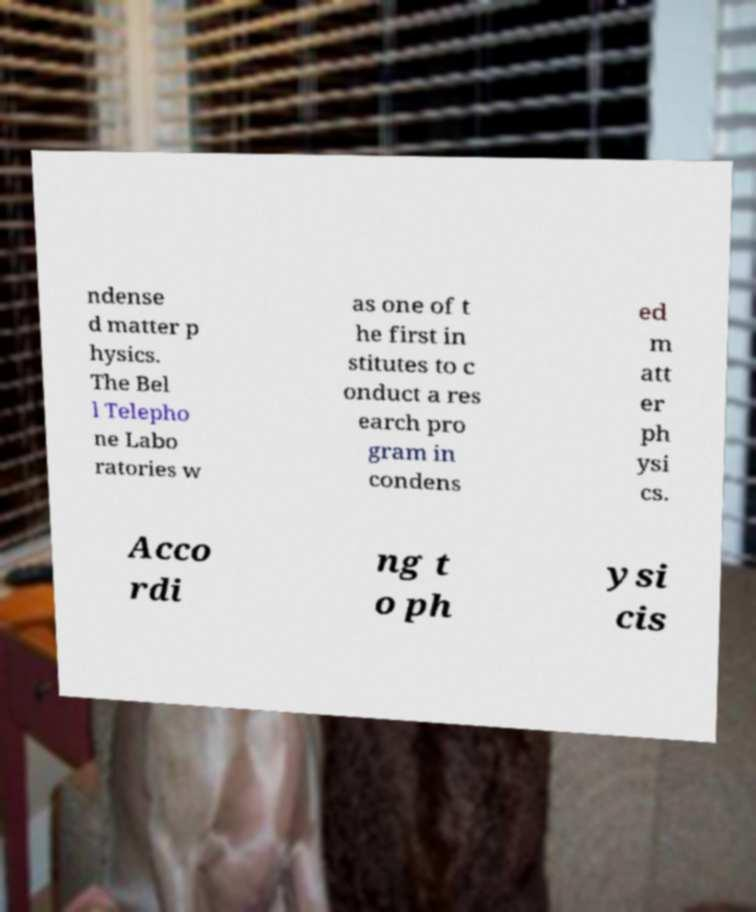Please identify and transcribe the text found in this image. ndense d matter p hysics. The Bel l Telepho ne Labo ratories w as one of t he first in stitutes to c onduct a res earch pro gram in condens ed m att er ph ysi cs. Acco rdi ng t o ph ysi cis 